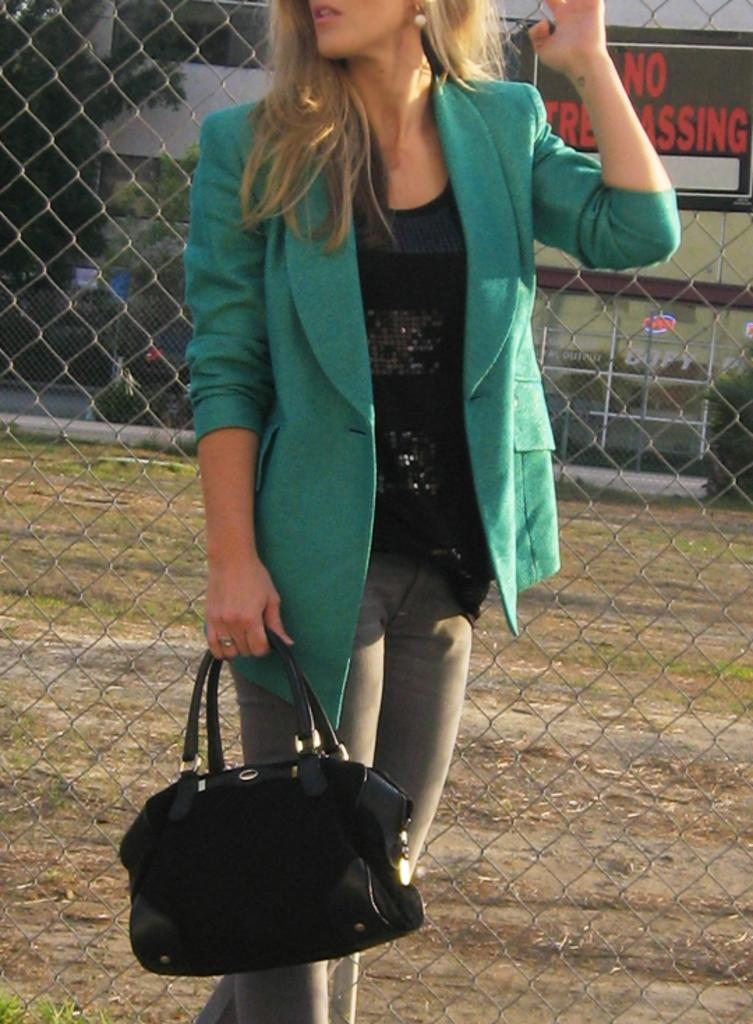Who is present in the image? There is a woman in the image. What is the woman holding in her hand? The woman is holding a bag with her hand. What can be seen in the background of the image? There is a fence, a building, and a tree in the background of the image. What type of wax is being used to sort the jars in the image? There is no wax or jars present in the image; it features a woman holding a bag and a background with a fence, building, and tree. 